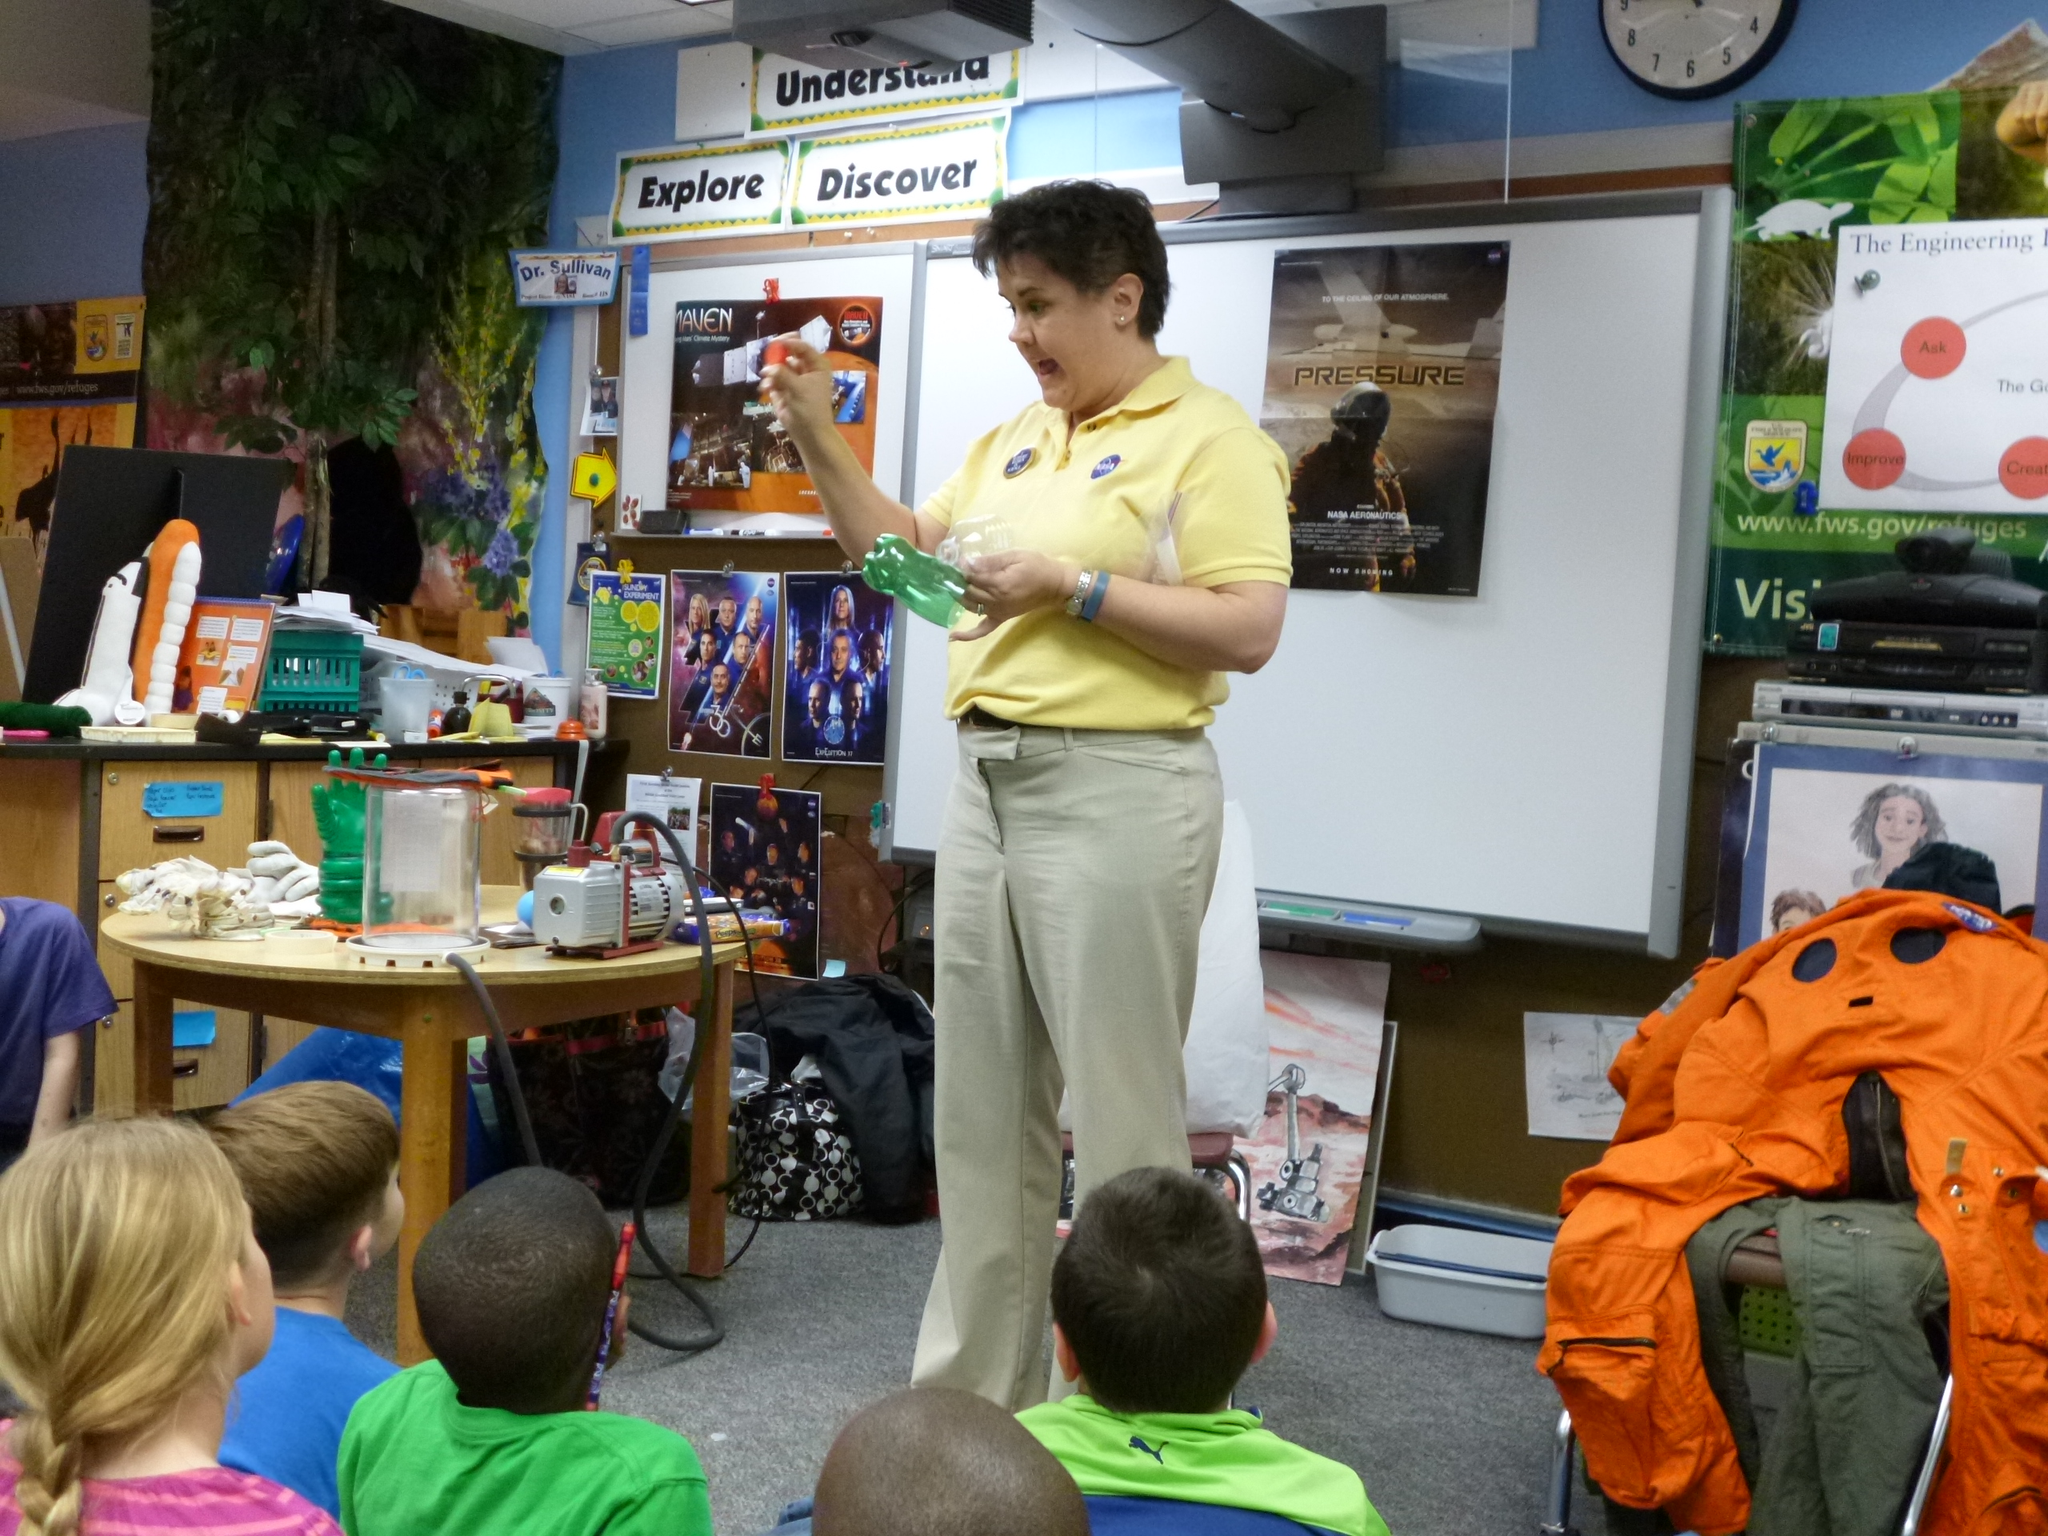How would you summarize this image in a sentence or two? This picture shows a woman standing and holding a bottle and we see few children seated and we see some bottles on the table 